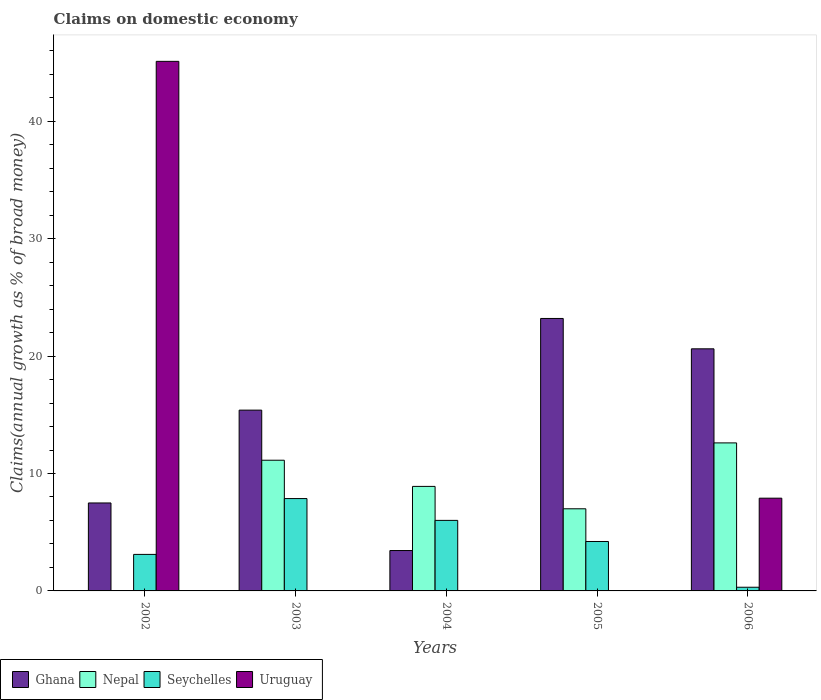How many bars are there on the 5th tick from the left?
Make the answer very short. 4. What is the label of the 5th group of bars from the left?
Your answer should be compact. 2006. In how many cases, is the number of bars for a given year not equal to the number of legend labels?
Give a very brief answer. 4. What is the percentage of broad money claimed on domestic economy in Ghana in 2005?
Offer a terse response. 23.2. Across all years, what is the maximum percentage of broad money claimed on domestic economy in Seychelles?
Your response must be concise. 7.86. Across all years, what is the minimum percentage of broad money claimed on domestic economy in Seychelles?
Offer a very short reply. 0.31. In which year was the percentage of broad money claimed on domestic economy in Uruguay maximum?
Ensure brevity in your answer.  2002. What is the total percentage of broad money claimed on domestic economy in Nepal in the graph?
Ensure brevity in your answer.  39.63. What is the difference between the percentage of broad money claimed on domestic economy in Ghana in 2003 and that in 2004?
Provide a succinct answer. 11.96. What is the difference between the percentage of broad money claimed on domestic economy in Seychelles in 2005 and the percentage of broad money claimed on domestic economy in Nepal in 2003?
Ensure brevity in your answer.  -6.92. What is the average percentage of broad money claimed on domestic economy in Ghana per year?
Give a very brief answer. 14.03. In the year 2004, what is the difference between the percentage of broad money claimed on domestic economy in Ghana and percentage of broad money claimed on domestic economy in Seychelles?
Make the answer very short. -2.57. In how many years, is the percentage of broad money claimed on domestic economy in Uruguay greater than 18 %?
Provide a succinct answer. 1. What is the ratio of the percentage of broad money claimed on domestic economy in Nepal in 2004 to that in 2005?
Provide a short and direct response. 1.27. Is the percentage of broad money claimed on domestic economy in Seychelles in 2002 less than that in 2005?
Ensure brevity in your answer.  Yes. Is the difference between the percentage of broad money claimed on domestic economy in Ghana in 2002 and 2005 greater than the difference between the percentage of broad money claimed on domestic economy in Seychelles in 2002 and 2005?
Provide a short and direct response. No. What is the difference between the highest and the second highest percentage of broad money claimed on domestic economy in Seychelles?
Ensure brevity in your answer.  1.86. What is the difference between the highest and the lowest percentage of broad money claimed on domestic economy in Ghana?
Provide a succinct answer. 19.76. In how many years, is the percentage of broad money claimed on domestic economy in Uruguay greater than the average percentage of broad money claimed on domestic economy in Uruguay taken over all years?
Your response must be concise. 1. Is the sum of the percentage of broad money claimed on domestic economy in Ghana in 2003 and 2006 greater than the maximum percentage of broad money claimed on domestic economy in Seychelles across all years?
Ensure brevity in your answer.  Yes. Is it the case that in every year, the sum of the percentage of broad money claimed on domestic economy in Nepal and percentage of broad money claimed on domestic economy in Seychelles is greater than the sum of percentage of broad money claimed on domestic economy in Uruguay and percentage of broad money claimed on domestic economy in Ghana?
Make the answer very short. No. Is it the case that in every year, the sum of the percentage of broad money claimed on domestic economy in Seychelles and percentage of broad money claimed on domestic economy in Ghana is greater than the percentage of broad money claimed on domestic economy in Uruguay?
Provide a short and direct response. No. How many bars are there?
Your response must be concise. 16. Are all the bars in the graph horizontal?
Offer a terse response. No. How many years are there in the graph?
Give a very brief answer. 5. Does the graph contain grids?
Provide a succinct answer. No. How are the legend labels stacked?
Ensure brevity in your answer.  Horizontal. What is the title of the graph?
Your response must be concise. Claims on domestic economy. Does "Uzbekistan" appear as one of the legend labels in the graph?
Offer a terse response. No. What is the label or title of the X-axis?
Keep it short and to the point. Years. What is the label or title of the Y-axis?
Give a very brief answer. Claims(annual growth as % of broad money). What is the Claims(annual growth as % of broad money) of Ghana in 2002?
Keep it short and to the point. 7.49. What is the Claims(annual growth as % of broad money) in Nepal in 2002?
Offer a terse response. 0. What is the Claims(annual growth as % of broad money) of Seychelles in 2002?
Make the answer very short. 3.11. What is the Claims(annual growth as % of broad money) of Uruguay in 2002?
Make the answer very short. 45.1. What is the Claims(annual growth as % of broad money) in Ghana in 2003?
Keep it short and to the point. 15.4. What is the Claims(annual growth as % of broad money) in Nepal in 2003?
Provide a short and direct response. 11.13. What is the Claims(annual growth as % of broad money) of Seychelles in 2003?
Keep it short and to the point. 7.86. What is the Claims(annual growth as % of broad money) of Ghana in 2004?
Ensure brevity in your answer.  3.44. What is the Claims(annual growth as % of broad money) of Nepal in 2004?
Ensure brevity in your answer.  8.9. What is the Claims(annual growth as % of broad money) of Seychelles in 2004?
Your answer should be compact. 6.01. What is the Claims(annual growth as % of broad money) in Uruguay in 2004?
Your answer should be very brief. 0. What is the Claims(annual growth as % of broad money) in Ghana in 2005?
Keep it short and to the point. 23.2. What is the Claims(annual growth as % of broad money) of Nepal in 2005?
Provide a short and direct response. 6.99. What is the Claims(annual growth as % of broad money) in Seychelles in 2005?
Your answer should be compact. 4.21. What is the Claims(annual growth as % of broad money) of Uruguay in 2005?
Provide a short and direct response. 0. What is the Claims(annual growth as % of broad money) in Ghana in 2006?
Offer a very short reply. 20.62. What is the Claims(annual growth as % of broad money) of Nepal in 2006?
Keep it short and to the point. 12.61. What is the Claims(annual growth as % of broad money) in Seychelles in 2006?
Provide a short and direct response. 0.31. What is the Claims(annual growth as % of broad money) of Uruguay in 2006?
Offer a very short reply. 7.9. Across all years, what is the maximum Claims(annual growth as % of broad money) of Ghana?
Make the answer very short. 23.2. Across all years, what is the maximum Claims(annual growth as % of broad money) of Nepal?
Offer a terse response. 12.61. Across all years, what is the maximum Claims(annual growth as % of broad money) in Seychelles?
Your response must be concise. 7.86. Across all years, what is the maximum Claims(annual growth as % of broad money) in Uruguay?
Your response must be concise. 45.1. Across all years, what is the minimum Claims(annual growth as % of broad money) of Ghana?
Keep it short and to the point. 3.44. Across all years, what is the minimum Claims(annual growth as % of broad money) of Nepal?
Your response must be concise. 0. Across all years, what is the minimum Claims(annual growth as % of broad money) in Seychelles?
Your answer should be compact. 0.31. Across all years, what is the minimum Claims(annual growth as % of broad money) of Uruguay?
Your answer should be very brief. 0. What is the total Claims(annual growth as % of broad money) in Ghana in the graph?
Provide a short and direct response. 70.15. What is the total Claims(annual growth as % of broad money) in Nepal in the graph?
Make the answer very short. 39.63. What is the total Claims(annual growth as % of broad money) in Seychelles in the graph?
Make the answer very short. 21.5. What is the total Claims(annual growth as % of broad money) of Uruguay in the graph?
Provide a short and direct response. 53. What is the difference between the Claims(annual growth as % of broad money) in Ghana in 2002 and that in 2003?
Ensure brevity in your answer.  -7.9. What is the difference between the Claims(annual growth as % of broad money) of Seychelles in 2002 and that in 2003?
Provide a succinct answer. -4.75. What is the difference between the Claims(annual growth as % of broad money) of Ghana in 2002 and that in 2004?
Offer a terse response. 4.05. What is the difference between the Claims(annual growth as % of broad money) of Seychelles in 2002 and that in 2004?
Keep it short and to the point. -2.9. What is the difference between the Claims(annual growth as % of broad money) in Ghana in 2002 and that in 2005?
Your response must be concise. -15.71. What is the difference between the Claims(annual growth as % of broad money) in Seychelles in 2002 and that in 2005?
Offer a very short reply. -1.1. What is the difference between the Claims(annual growth as % of broad money) in Ghana in 2002 and that in 2006?
Provide a short and direct response. -13.13. What is the difference between the Claims(annual growth as % of broad money) of Seychelles in 2002 and that in 2006?
Provide a short and direct response. 2.8. What is the difference between the Claims(annual growth as % of broad money) in Uruguay in 2002 and that in 2006?
Ensure brevity in your answer.  37.2. What is the difference between the Claims(annual growth as % of broad money) of Ghana in 2003 and that in 2004?
Provide a succinct answer. 11.96. What is the difference between the Claims(annual growth as % of broad money) of Nepal in 2003 and that in 2004?
Ensure brevity in your answer.  2.23. What is the difference between the Claims(annual growth as % of broad money) of Seychelles in 2003 and that in 2004?
Make the answer very short. 1.86. What is the difference between the Claims(annual growth as % of broad money) in Ghana in 2003 and that in 2005?
Give a very brief answer. -7.81. What is the difference between the Claims(annual growth as % of broad money) of Nepal in 2003 and that in 2005?
Ensure brevity in your answer.  4.14. What is the difference between the Claims(annual growth as % of broad money) of Seychelles in 2003 and that in 2005?
Make the answer very short. 3.65. What is the difference between the Claims(annual growth as % of broad money) in Ghana in 2003 and that in 2006?
Ensure brevity in your answer.  -5.22. What is the difference between the Claims(annual growth as % of broad money) in Nepal in 2003 and that in 2006?
Your answer should be compact. -1.48. What is the difference between the Claims(annual growth as % of broad money) of Seychelles in 2003 and that in 2006?
Make the answer very short. 7.55. What is the difference between the Claims(annual growth as % of broad money) in Ghana in 2004 and that in 2005?
Your answer should be compact. -19.76. What is the difference between the Claims(annual growth as % of broad money) in Nepal in 2004 and that in 2005?
Provide a short and direct response. 1.91. What is the difference between the Claims(annual growth as % of broad money) in Seychelles in 2004 and that in 2005?
Offer a terse response. 1.8. What is the difference between the Claims(annual growth as % of broad money) in Ghana in 2004 and that in 2006?
Your answer should be very brief. -17.18. What is the difference between the Claims(annual growth as % of broad money) of Nepal in 2004 and that in 2006?
Your answer should be compact. -3.7. What is the difference between the Claims(annual growth as % of broad money) of Seychelles in 2004 and that in 2006?
Your response must be concise. 5.69. What is the difference between the Claims(annual growth as % of broad money) of Ghana in 2005 and that in 2006?
Provide a succinct answer. 2.59. What is the difference between the Claims(annual growth as % of broad money) in Nepal in 2005 and that in 2006?
Your response must be concise. -5.61. What is the difference between the Claims(annual growth as % of broad money) of Seychelles in 2005 and that in 2006?
Your response must be concise. 3.9. What is the difference between the Claims(annual growth as % of broad money) of Ghana in 2002 and the Claims(annual growth as % of broad money) of Nepal in 2003?
Make the answer very short. -3.64. What is the difference between the Claims(annual growth as % of broad money) in Ghana in 2002 and the Claims(annual growth as % of broad money) in Seychelles in 2003?
Provide a succinct answer. -0.37. What is the difference between the Claims(annual growth as % of broad money) in Ghana in 2002 and the Claims(annual growth as % of broad money) in Nepal in 2004?
Offer a terse response. -1.41. What is the difference between the Claims(annual growth as % of broad money) in Ghana in 2002 and the Claims(annual growth as % of broad money) in Seychelles in 2004?
Ensure brevity in your answer.  1.48. What is the difference between the Claims(annual growth as % of broad money) of Ghana in 2002 and the Claims(annual growth as % of broad money) of Nepal in 2005?
Offer a terse response. 0.5. What is the difference between the Claims(annual growth as % of broad money) in Ghana in 2002 and the Claims(annual growth as % of broad money) in Seychelles in 2005?
Your response must be concise. 3.28. What is the difference between the Claims(annual growth as % of broad money) in Ghana in 2002 and the Claims(annual growth as % of broad money) in Nepal in 2006?
Offer a terse response. -5.11. What is the difference between the Claims(annual growth as % of broad money) of Ghana in 2002 and the Claims(annual growth as % of broad money) of Seychelles in 2006?
Provide a succinct answer. 7.18. What is the difference between the Claims(annual growth as % of broad money) in Ghana in 2002 and the Claims(annual growth as % of broad money) in Uruguay in 2006?
Your answer should be compact. -0.41. What is the difference between the Claims(annual growth as % of broad money) of Seychelles in 2002 and the Claims(annual growth as % of broad money) of Uruguay in 2006?
Ensure brevity in your answer.  -4.79. What is the difference between the Claims(annual growth as % of broad money) in Ghana in 2003 and the Claims(annual growth as % of broad money) in Nepal in 2004?
Your answer should be very brief. 6.49. What is the difference between the Claims(annual growth as % of broad money) in Ghana in 2003 and the Claims(annual growth as % of broad money) in Seychelles in 2004?
Provide a short and direct response. 9.39. What is the difference between the Claims(annual growth as % of broad money) in Nepal in 2003 and the Claims(annual growth as % of broad money) in Seychelles in 2004?
Offer a very short reply. 5.12. What is the difference between the Claims(annual growth as % of broad money) in Ghana in 2003 and the Claims(annual growth as % of broad money) in Nepal in 2005?
Make the answer very short. 8.4. What is the difference between the Claims(annual growth as % of broad money) in Ghana in 2003 and the Claims(annual growth as % of broad money) in Seychelles in 2005?
Keep it short and to the point. 11.19. What is the difference between the Claims(annual growth as % of broad money) in Nepal in 2003 and the Claims(annual growth as % of broad money) in Seychelles in 2005?
Make the answer very short. 6.92. What is the difference between the Claims(annual growth as % of broad money) of Ghana in 2003 and the Claims(annual growth as % of broad money) of Nepal in 2006?
Ensure brevity in your answer.  2.79. What is the difference between the Claims(annual growth as % of broad money) in Ghana in 2003 and the Claims(annual growth as % of broad money) in Seychelles in 2006?
Provide a short and direct response. 15.08. What is the difference between the Claims(annual growth as % of broad money) in Ghana in 2003 and the Claims(annual growth as % of broad money) in Uruguay in 2006?
Offer a very short reply. 7.5. What is the difference between the Claims(annual growth as % of broad money) of Nepal in 2003 and the Claims(annual growth as % of broad money) of Seychelles in 2006?
Offer a terse response. 10.82. What is the difference between the Claims(annual growth as % of broad money) in Nepal in 2003 and the Claims(annual growth as % of broad money) in Uruguay in 2006?
Your answer should be very brief. 3.23. What is the difference between the Claims(annual growth as % of broad money) of Seychelles in 2003 and the Claims(annual growth as % of broad money) of Uruguay in 2006?
Keep it short and to the point. -0.03. What is the difference between the Claims(annual growth as % of broad money) of Ghana in 2004 and the Claims(annual growth as % of broad money) of Nepal in 2005?
Provide a short and direct response. -3.55. What is the difference between the Claims(annual growth as % of broad money) in Ghana in 2004 and the Claims(annual growth as % of broad money) in Seychelles in 2005?
Provide a succinct answer. -0.77. What is the difference between the Claims(annual growth as % of broad money) in Nepal in 2004 and the Claims(annual growth as % of broad money) in Seychelles in 2005?
Keep it short and to the point. 4.69. What is the difference between the Claims(annual growth as % of broad money) of Ghana in 2004 and the Claims(annual growth as % of broad money) of Nepal in 2006?
Provide a succinct answer. -9.17. What is the difference between the Claims(annual growth as % of broad money) in Ghana in 2004 and the Claims(annual growth as % of broad money) in Seychelles in 2006?
Your response must be concise. 3.13. What is the difference between the Claims(annual growth as % of broad money) of Ghana in 2004 and the Claims(annual growth as % of broad money) of Uruguay in 2006?
Offer a very short reply. -4.46. What is the difference between the Claims(annual growth as % of broad money) in Nepal in 2004 and the Claims(annual growth as % of broad money) in Seychelles in 2006?
Offer a very short reply. 8.59. What is the difference between the Claims(annual growth as % of broad money) in Seychelles in 2004 and the Claims(annual growth as % of broad money) in Uruguay in 2006?
Offer a very short reply. -1.89. What is the difference between the Claims(annual growth as % of broad money) of Ghana in 2005 and the Claims(annual growth as % of broad money) of Nepal in 2006?
Provide a succinct answer. 10.6. What is the difference between the Claims(annual growth as % of broad money) in Ghana in 2005 and the Claims(annual growth as % of broad money) in Seychelles in 2006?
Ensure brevity in your answer.  22.89. What is the difference between the Claims(annual growth as % of broad money) of Ghana in 2005 and the Claims(annual growth as % of broad money) of Uruguay in 2006?
Provide a succinct answer. 15.3. What is the difference between the Claims(annual growth as % of broad money) in Nepal in 2005 and the Claims(annual growth as % of broad money) in Seychelles in 2006?
Provide a succinct answer. 6.68. What is the difference between the Claims(annual growth as % of broad money) in Nepal in 2005 and the Claims(annual growth as % of broad money) in Uruguay in 2006?
Offer a terse response. -0.9. What is the difference between the Claims(annual growth as % of broad money) in Seychelles in 2005 and the Claims(annual growth as % of broad money) in Uruguay in 2006?
Ensure brevity in your answer.  -3.69. What is the average Claims(annual growth as % of broad money) of Ghana per year?
Give a very brief answer. 14.03. What is the average Claims(annual growth as % of broad money) of Nepal per year?
Ensure brevity in your answer.  7.93. What is the average Claims(annual growth as % of broad money) of Seychelles per year?
Give a very brief answer. 4.3. What is the average Claims(annual growth as % of broad money) in Uruguay per year?
Ensure brevity in your answer.  10.6. In the year 2002, what is the difference between the Claims(annual growth as % of broad money) in Ghana and Claims(annual growth as % of broad money) in Seychelles?
Your answer should be compact. 4.38. In the year 2002, what is the difference between the Claims(annual growth as % of broad money) of Ghana and Claims(annual growth as % of broad money) of Uruguay?
Make the answer very short. -37.61. In the year 2002, what is the difference between the Claims(annual growth as % of broad money) of Seychelles and Claims(annual growth as % of broad money) of Uruguay?
Keep it short and to the point. -41.99. In the year 2003, what is the difference between the Claims(annual growth as % of broad money) in Ghana and Claims(annual growth as % of broad money) in Nepal?
Your response must be concise. 4.27. In the year 2003, what is the difference between the Claims(annual growth as % of broad money) of Ghana and Claims(annual growth as % of broad money) of Seychelles?
Your answer should be very brief. 7.53. In the year 2003, what is the difference between the Claims(annual growth as % of broad money) of Nepal and Claims(annual growth as % of broad money) of Seychelles?
Offer a very short reply. 3.27. In the year 2004, what is the difference between the Claims(annual growth as % of broad money) in Ghana and Claims(annual growth as % of broad money) in Nepal?
Make the answer very short. -5.46. In the year 2004, what is the difference between the Claims(annual growth as % of broad money) in Ghana and Claims(annual growth as % of broad money) in Seychelles?
Your answer should be very brief. -2.57. In the year 2004, what is the difference between the Claims(annual growth as % of broad money) of Nepal and Claims(annual growth as % of broad money) of Seychelles?
Give a very brief answer. 2.9. In the year 2005, what is the difference between the Claims(annual growth as % of broad money) in Ghana and Claims(annual growth as % of broad money) in Nepal?
Give a very brief answer. 16.21. In the year 2005, what is the difference between the Claims(annual growth as % of broad money) of Ghana and Claims(annual growth as % of broad money) of Seychelles?
Ensure brevity in your answer.  18.99. In the year 2005, what is the difference between the Claims(annual growth as % of broad money) in Nepal and Claims(annual growth as % of broad money) in Seychelles?
Your answer should be compact. 2.78. In the year 2006, what is the difference between the Claims(annual growth as % of broad money) in Ghana and Claims(annual growth as % of broad money) in Nepal?
Provide a short and direct response. 8.01. In the year 2006, what is the difference between the Claims(annual growth as % of broad money) of Ghana and Claims(annual growth as % of broad money) of Seychelles?
Make the answer very short. 20.3. In the year 2006, what is the difference between the Claims(annual growth as % of broad money) in Ghana and Claims(annual growth as % of broad money) in Uruguay?
Provide a short and direct response. 12.72. In the year 2006, what is the difference between the Claims(annual growth as % of broad money) in Nepal and Claims(annual growth as % of broad money) in Seychelles?
Ensure brevity in your answer.  12.29. In the year 2006, what is the difference between the Claims(annual growth as % of broad money) of Nepal and Claims(annual growth as % of broad money) of Uruguay?
Provide a succinct answer. 4.71. In the year 2006, what is the difference between the Claims(annual growth as % of broad money) of Seychelles and Claims(annual growth as % of broad money) of Uruguay?
Ensure brevity in your answer.  -7.58. What is the ratio of the Claims(annual growth as % of broad money) in Ghana in 2002 to that in 2003?
Offer a terse response. 0.49. What is the ratio of the Claims(annual growth as % of broad money) of Seychelles in 2002 to that in 2003?
Provide a short and direct response. 0.4. What is the ratio of the Claims(annual growth as % of broad money) in Ghana in 2002 to that in 2004?
Your response must be concise. 2.18. What is the ratio of the Claims(annual growth as % of broad money) in Seychelles in 2002 to that in 2004?
Give a very brief answer. 0.52. What is the ratio of the Claims(annual growth as % of broad money) in Ghana in 2002 to that in 2005?
Give a very brief answer. 0.32. What is the ratio of the Claims(annual growth as % of broad money) of Seychelles in 2002 to that in 2005?
Your answer should be compact. 0.74. What is the ratio of the Claims(annual growth as % of broad money) in Ghana in 2002 to that in 2006?
Offer a very short reply. 0.36. What is the ratio of the Claims(annual growth as % of broad money) of Seychelles in 2002 to that in 2006?
Ensure brevity in your answer.  9.92. What is the ratio of the Claims(annual growth as % of broad money) in Uruguay in 2002 to that in 2006?
Give a very brief answer. 5.71. What is the ratio of the Claims(annual growth as % of broad money) in Ghana in 2003 to that in 2004?
Your response must be concise. 4.48. What is the ratio of the Claims(annual growth as % of broad money) in Nepal in 2003 to that in 2004?
Keep it short and to the point. 1.25. What is the ratio of the Claims(annual growth as % of broad money) in Seychelles in 2003 to that in 2004?
Provide a succinct answer. 1.31. What is the ratio of the Claims(annual growth as % of broad money) of Ghana in 2003 to that in 2005?
Give a very brief answer. 0.66. What is the ratio of the Claims(annual growth as % of broad money) of Nepal in 2003 to that in 2005?
Offer a very short reply. 1.59. What is the ratio of the Claims(annual growth as % of broad money) of Seychelles in 2003 to that in 2005?
Your answer should be very brief. 1.87. What is the ratio of the Claims(annual growth as % of broad money) of Ghana in 2003 to that in 2006?
Offer a terse response. 0.75. What is the ratio of the Claims(annual growth as % of broad money) in Nepal in 2003 to that in 2006?
Give a very brief answer. 0.88. What is the ratio of the Claims(annual growth as % of broad money) in Seychelles in 2003 to that in 2006?
Ensure brevity in your answer.  25.08. What is the ratio of the Claims(annual growth as % of broad money) in Ghana in 2004 to that in 2005?
Offer a very short reply. 0.15. What is the ratio of the Claims(annual growth as % of broad money) of Nepal in 2004 to that in 2005?
Your response must be concise. 1.27. What is the ratio of the Claims(annual growth as % of broad money) of Seychelles in 2004 to that in 2005?
Provide a short and direct response. 1.43. What is the ratio of the Claims(annual growth as % of broad money) in Ghana in 2004 to that in 2006?
Give a very brief answer. 0.17. What is the ratio of the Claims(annual growth as % of broad money) in Nepal in 2004 to that in 2006?
Offer a very short reply. 0.71. What is the ratio of the Claims(annual growth as % of broad money) in Seychelles in 2004 to that in 2006?
Give a very brief answer. 19.16. What is the ratio of the Claims(annual growth as % of broad money) of Ghana in 2005 to that in 2006?
Provide a succinct answer. 1.13. What is the ratio of the Claims(annual growth as % of broad money) of Nepal in 2005 to that in 2006?
Offer a terse response. 0.55. What is the ratio of the Claims(annual growth as % of broad money) of Seychelles in 2005 to that in 2006?
Provide a succinct answer. 13.43. What is the difference between the highest and the second highest Claims(annual growth as % of broad money) of Ghana?
Provide a short and direct response. 2.59. What is the difference between the highest and the second highest Claims(annual growth as % of broad money) of Nepal?
Your response must be concise. 1.48. What is the difference between the highest and the second highest Claims(annual growth as % of broad money) of Seychelles?
Your response must be concise. 1.86. What is the difference between the highest and the lowest Claims(annual growth as % of broad money) of Ghana?
Offer a very short reply. 19.76. What is the difference between the highest and the lowest Claims(annual growth as % of broad money) in Nepal?
Keep it short and to the point. 12.61. What is the difference between the highest and the lowest Claims(annual growth as % of broad money) in Seychelles?
Your answer should be very brief. 7.55. What is the difference between the highest and the lowest Claims(annual growth as % of broad money) of Uruguay?
Offer a very short reply. 45.1. 